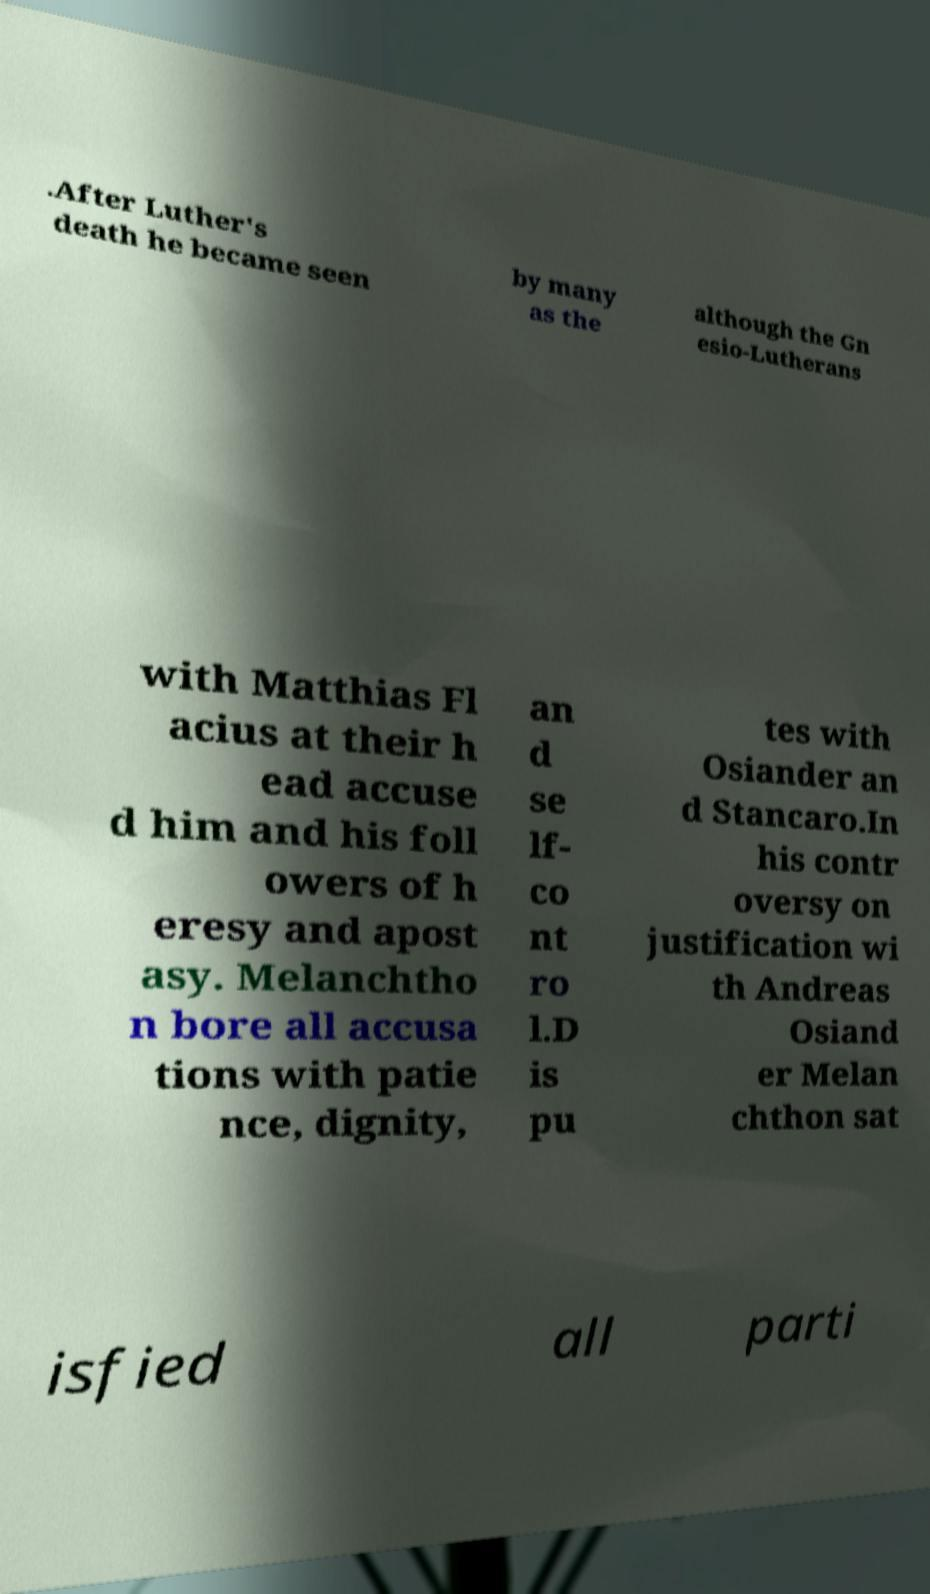What messages or text are displayed in this image? I need them in a readable, typed format. .After Luther's death he became seen by many as the although the Gn esio-Lutherans with Matthias Fl acius at their h ead accuse d him and his foll owers of h eresy and apost asy. Melanchtho n bore all accusa tions with patie nce, dignity, an d se lf- co nt ro l.D is pu tes with Osiander an d Stancaro.In his contr oversy on justification wi th Andreas Osiand er Melan chthon sat isfied all parti 